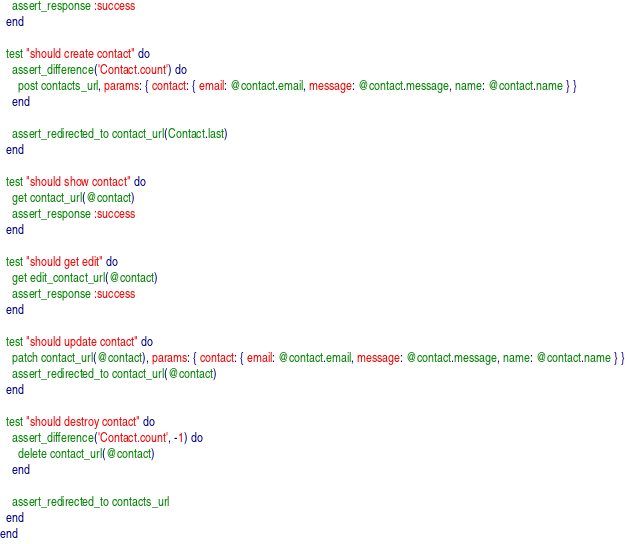<code> <loc_0><loc_0><loc_500><loc_500><_Ruby_>    assert_response :success
  end

  test "should create contact" do
    assert_difference('Contact.count') do
      post contacts_url, params: { contact: { email: @contact.email, message: @contact.message, name: @contact.name } }
    end

    assert_redirected_to contact_url(Contact.last)
  end

  test "should show contact" do
    get contact_url(@contact)
    assert_response :success
  end

  test "should get edit" do
    get edit_contact_url(@contact)
    assert_response :success
  end

  test "should update contact" do
    patch contact_url(@contact), params: { contact: { email: @contact.email, message: @contact.message, name: @contact.name } }
    assert_redirected_to contact_url(@contact)
  end

  test "should destroy contact" do
    assert_difference('Contact.count', -1) do
      delete contact_url(@contact)
    end

    assert_redirected_to contacts_url
  end
end
</code> 